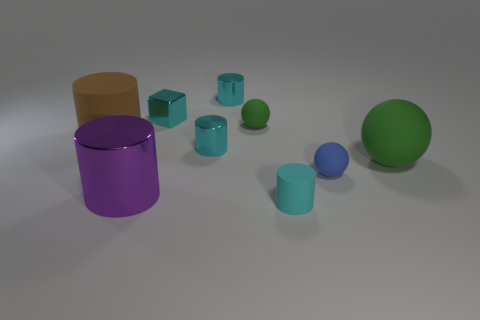How many cyan cylinders must be subtracted to get 1 cyan cylinders? 2 Subtract all gray blocks. How many cyan cylinders are left? 3 Subtract all brown cylinders. How many cylinders are left? 4 Subtract all large matte cylinders. How many cylinders are left? 4 Subtract all blue cylinders. Subtract all purple cubes. How many cylinders are left? 5 Subtract all cubes. How many objects are left? 8 Add 7 brown matte cylinders. How many brown matte cylinders are left? 8 Add 1 tiny cyan rubber cylinders. How many tiny cyan rubber cylinders exist? 2 Subtract 2 green balls. How many objects are left? 7 Subtract all big spheres. Subtract all tiny blue balls. How many objects are left? 7 